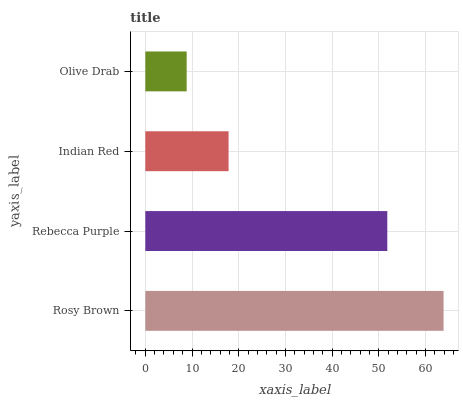Is Olive Drab the minimum?
Answer yes or no. Yes. Is Rosy Brown the maximum?
Answer yes or no. Yes. Is Rebecca Purple the minimum?
Answer yes or no. No. Is Rebecca Purple the maximum?
Answer yes or no. No. Is Rosy Brown greater than Rebecca Purple?
Answer yes or no. Yes. Is Rebecca Purple less than Rosy Brown?
Answer yes or no. Yes. Is Rebecca Purple greater than Rosy Brown?
Answer yes or no. No. Is Rosy Brown less than Rebecca Purple?
Answer yes or no. No. Is Rebecca Purple the high median?
Answer yes or no. Yes. Is Indian Red the low median?
Answer yes or no. Yes. Is Rosy Brown the high median?
Answer yes or no. No. Is Olive Drab the low median?
Answer yes or no. No. 